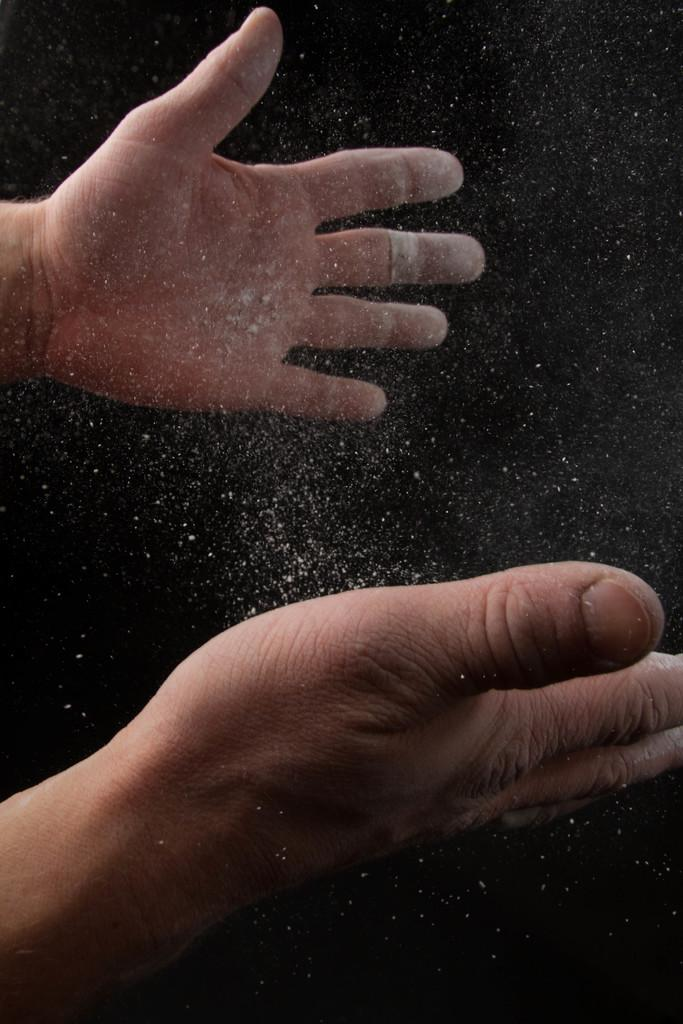What can be seen in the image involving hands? There are two hands in the image. What is present between the hands? There is powder between the hands. What type of copper material can be seen in the image? There is no copper material present in the image. What kind of wave is depicted in the image? There is no wave depicted in the image. 